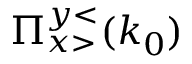<formula> <loc_0><loc_0><loc_500><loc_500>\Pi _ { x > } ^ { y < } ( k _ { 0 } )</formula> 